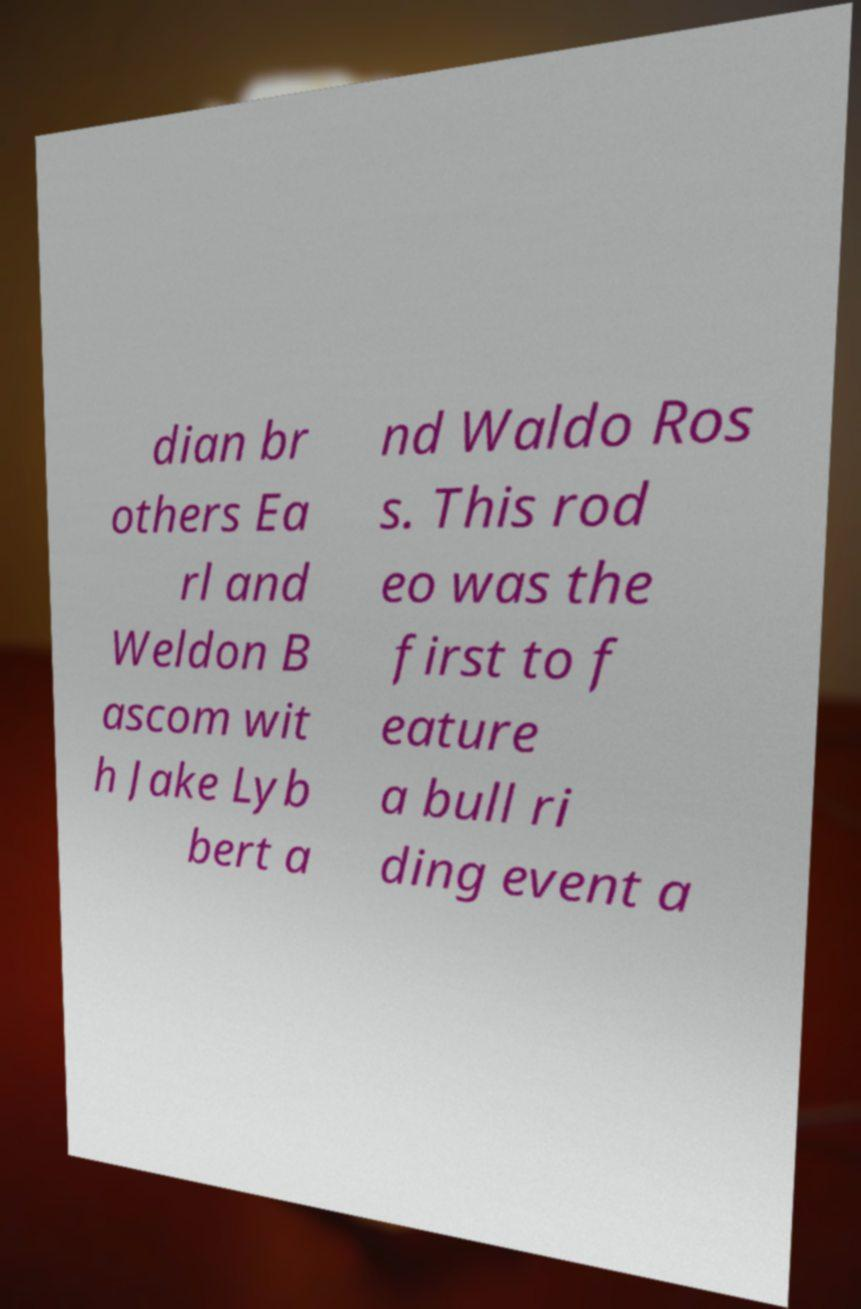Could you extract and type out the text from this image? dian br others Ea rl and Weldon B ascom wit h Jake Lyb bert a nd Waldo Ros s. This rod eo was the first to f eature a bull ri ding event a 